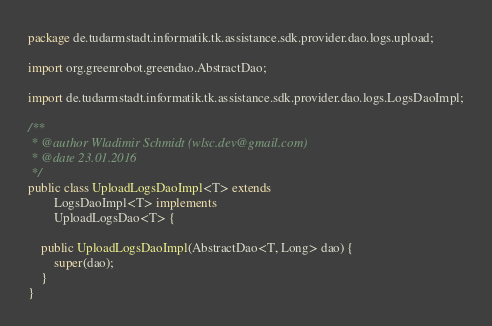Convert code to text. <code><loc_0><loc_0><loc_500><loc_500><_Java_>package de.tudarmstadt.informatik.tk.assistance.sdk.provider.dao.logs.upload;

import org.greenrobot.greendao.AbstractDao;

import de.tudarmstadt.informatik.tk.assistance.sdk.provider.dao.logs.LogsDaoImpl;

/**
 * @author Wladimir Schmidt (wlsc.dev@gmail.com)
 * @date 23.01.2016
 */
public class UploadLogsDaoImpl<T> extends
        LogsDaoImpl<T> implements
        UploadLogsDao<T> {

    public UploadLogsDaoImpl(AbstractDao<T, Long> dao) {
        super(dao);
    }
}</code> 